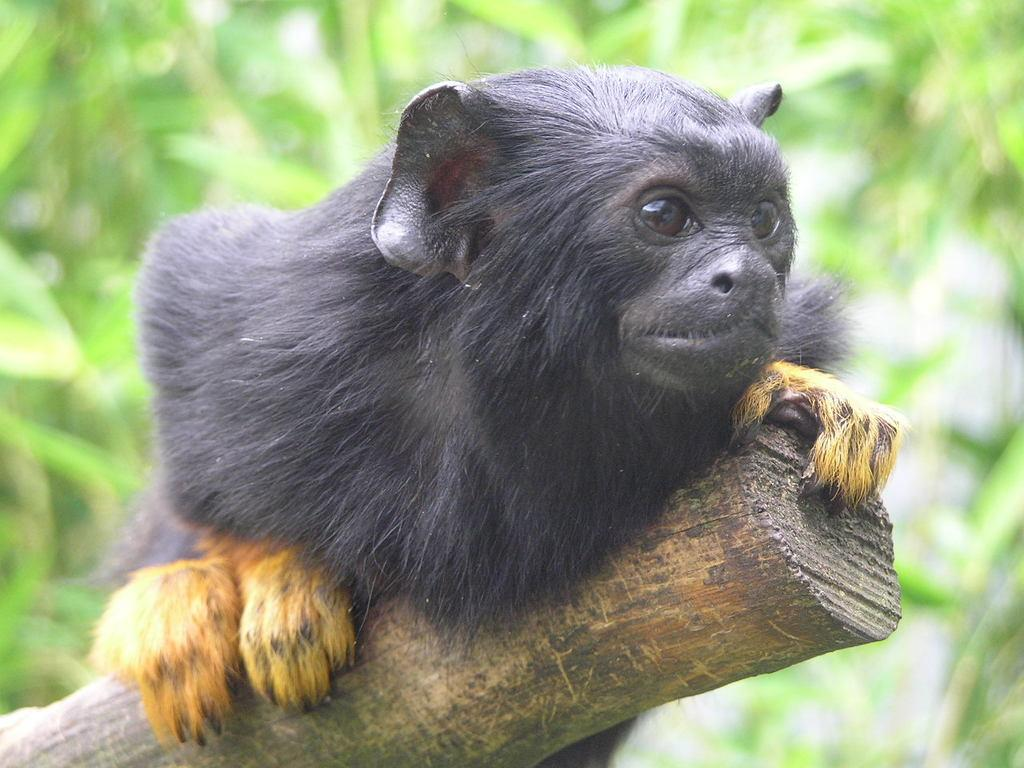What type of animal is in the image? There is an animal in the image, but the specific type cannot be determined from the provided facts. What is the animal holding in the image? The animal is holding a trunk in the image. What can be seen in the background of the image? There are trees in the background of the image. What color is the orange that the animal is shaking in the image? There is no orange present in the image, nor is there any indication that the animal is shaking anything. 